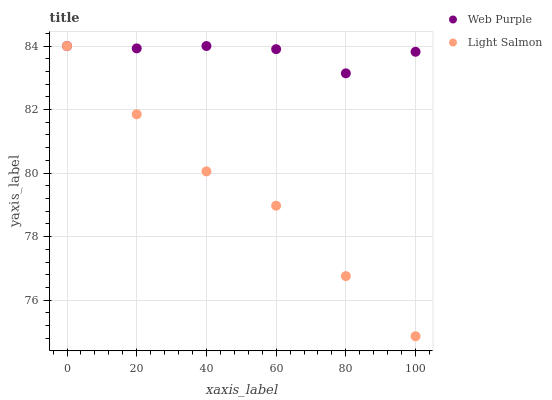Does Light Salmon have the minimum area under the curve?
Answer yes or no. Yes. Does Web Purple have the maximum area under the curve?
Answer yes or no. Yes. Does Light Salmon have the maximum area under the curve?
Answer yes or no. No. Is Web Purple the smoothest?
Answer yes or no. Yes. Is Light Salmon the roughest?
Answer yes or no. Yes. Is Light Salmon the smoothest?
Answer yes or no. No. Does Light Salmon have the lowest value?
Answer yes or no. Yes. Does Light Salmon have the highest value?
Answer yes or no. Yes. Does Light Salmon intersect Web Purple?
Answer yes or no. Yes. Is Light Salmon less than Web Purple?
Answer yes or no. No. Is Light Salmon greater than Web Purple?
Answer yes or no. No. 